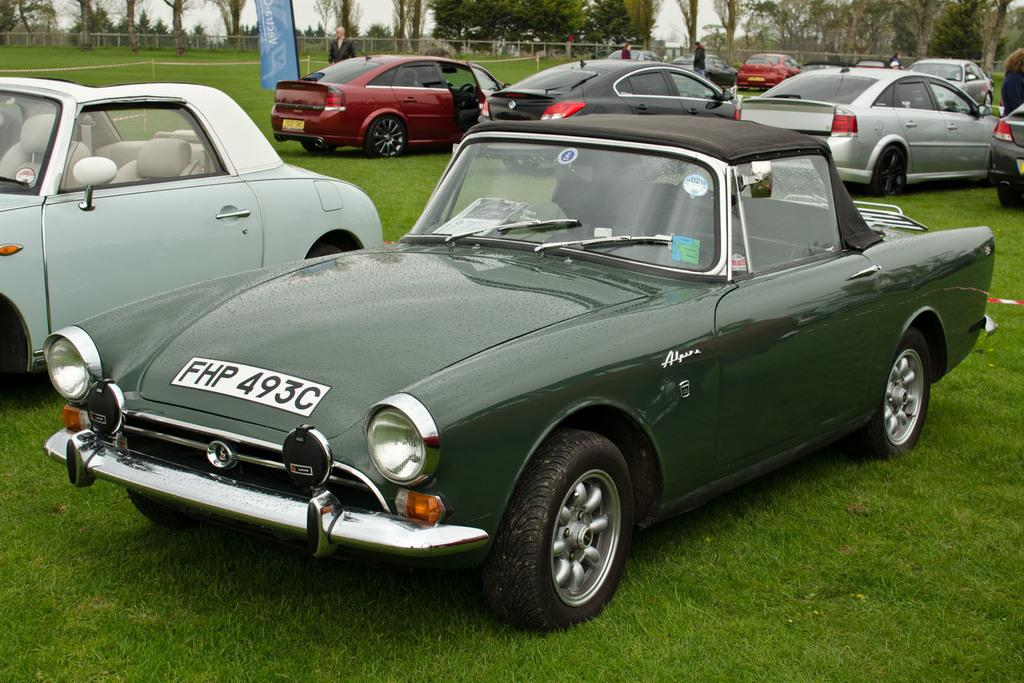What type of vehicles can be seen in the image? There are cars in the image. What else is present in the image besides the cars? There is a banner, grass, a fence, trees, and people visible in the image. Can you describe the background of the image? The background of the image includes a fence, trees, and people. What type of terrain is visible in the image? Grass is visible in the image. What is the purpose of the van in the image? There is no van present in the image; only cars are mentioned. 